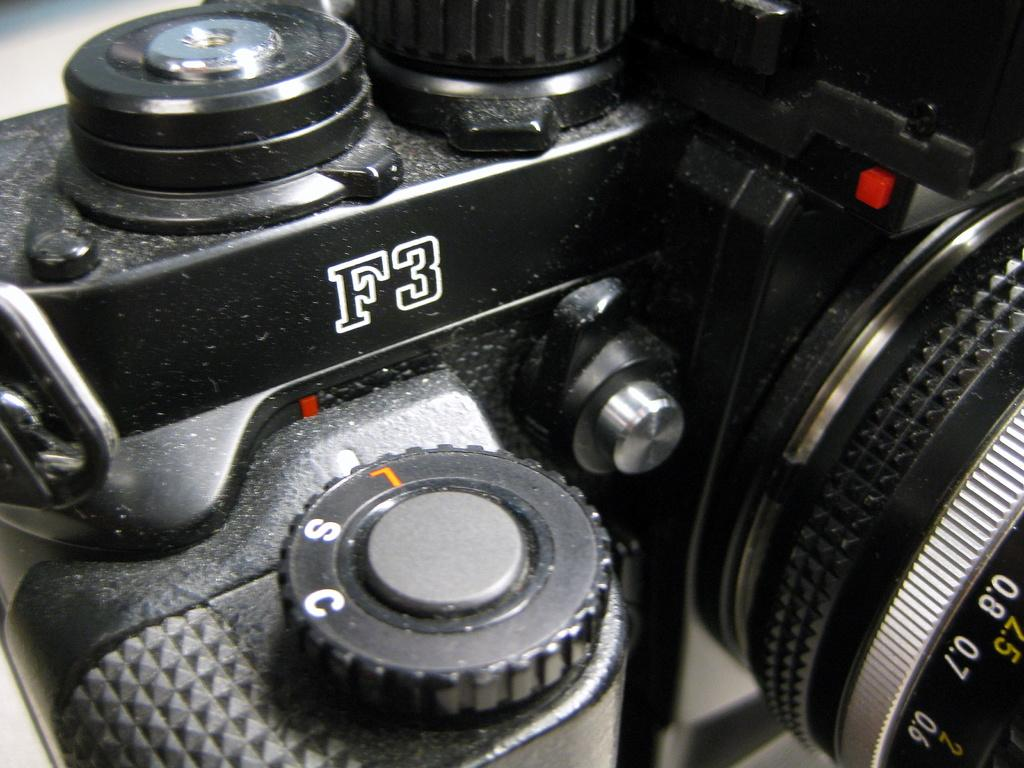What object has text and numbers visible on it in the image? There is text and numbers visible on a camera in the image. Can you describe the text and numbers on the camera? Unfortunately, the specific text and numbers cannot be described without more information about the camera model or context. How many cows are visible in the image? There are no cows present in the image; it features a camera with visible text and numbers. 